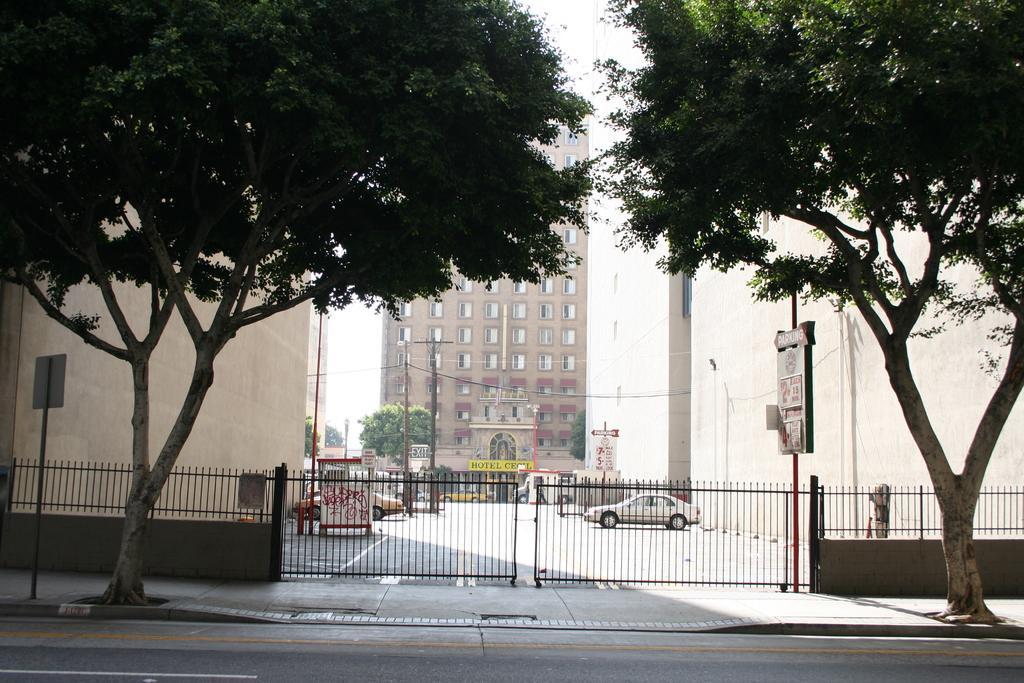Could you give a brief overview of what you see in this image? To the bottom of the image there is a road. Behind the road there is a footpath with trees and pole with sign boards. And behind the footpath there is a fencing with gates in the middle. Behind the gate there is a road with few cars. And also in the background there are many buildings with windows, walls and name boards. And also there are electrical poles and trees. 